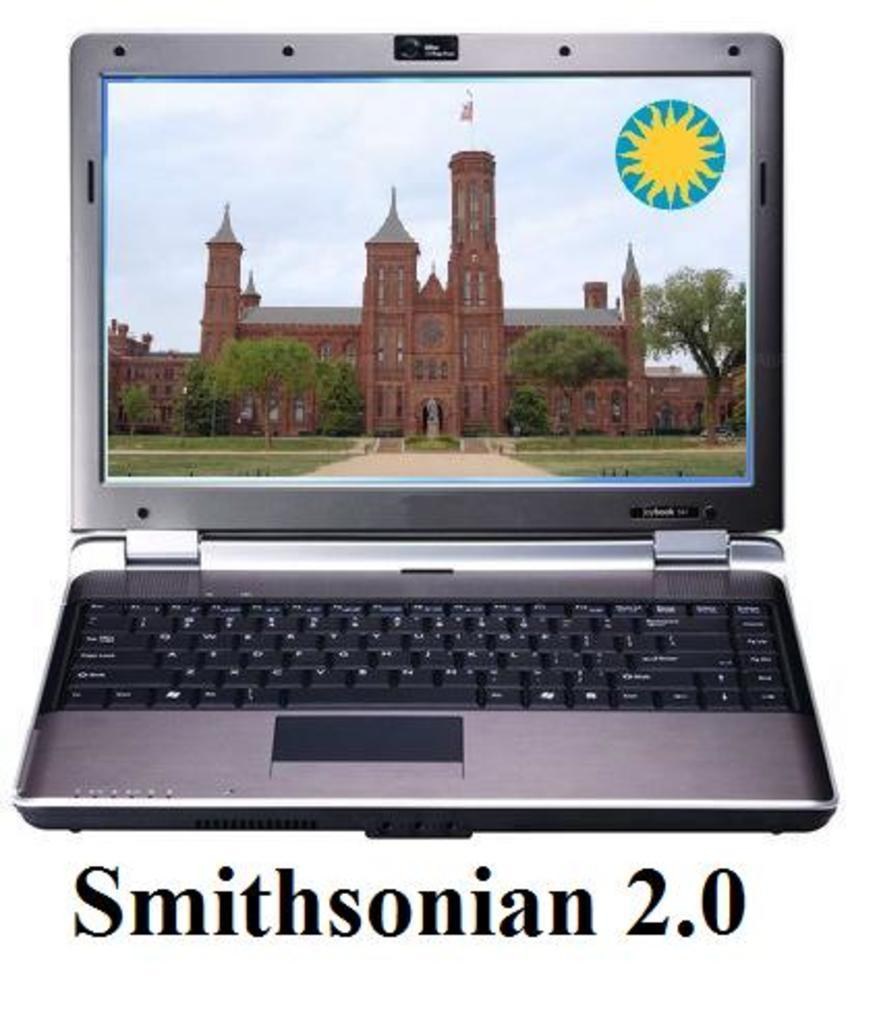Provide a one-sentence caption for the provided image. An old brick building called the Smithsonian is shown on a laptop screen. 